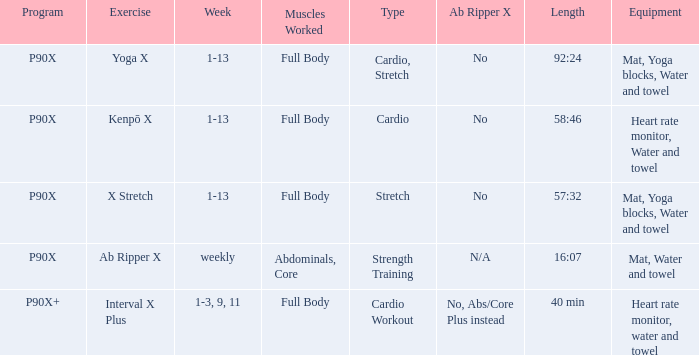How many categories are cardio? 1.0. 